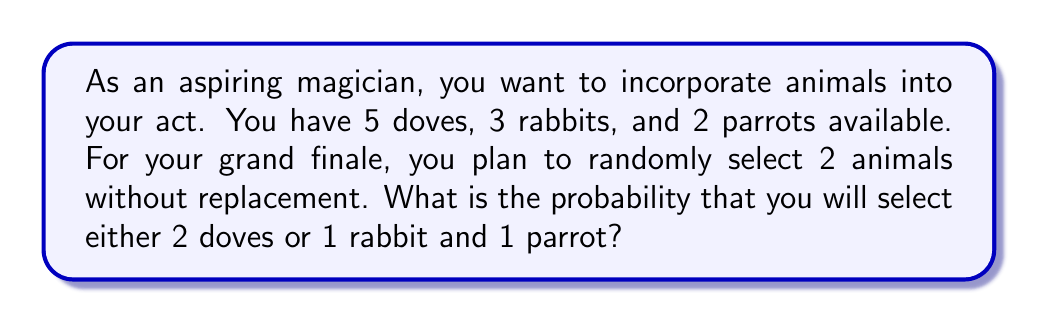Can you answer this question? Let's break this down step-by-step:

1) First, we need to calculate the total number of ways to select 2 animals out of 10. This is given by the combination formula:

   $${10 \choose 2} = \frac{10!}{2!(10-2)!} = \frac{10 \cdot 9}{2} = 45$$

2) Now, let's calculate the probability of selecting 2 doves:
   
   $${5 \choose 2} = \frac{5!}{2!(5-2)!} = \frac{5 \cdot 4}{2} = 10$$

   Probability = $\frac{10}{45}$

3) For selecting 1 rabbit and 1 parrot:
   
   Ways to select 1 rabbit: ${3 \choose 1} = 3$
   Ways to select 1 parrot: ${2 \choose 1} = 2$
   
   Total ways = $3 \cdot 2 = 6$

   Probability = $\frac{6}{45}$

4) The total probability is the sum of these two probabilities:

   $$P(\text{2 doves OR 1 rabbit and 1 parrot}) = \frac{10}{45} + \frac{6}{45} = \frac{16}{45}$$

5) Simplifying the fraction:

   $$\frac{16}{45} = \frac{16 \div 1}{45 \div 1} = \frac{16}{45}$$
Answer: $\frac{16}{45}$ or approximately 0.3556 